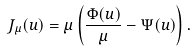Convert formula to latex. <formula><loc_0><loc_0><loc_500><loc_500>J _ { \mu } ( u ) = \mu \left ( \frac { \Phi ( u ) } { \mu } - \Psi ( u ) \right ) .</formula> 